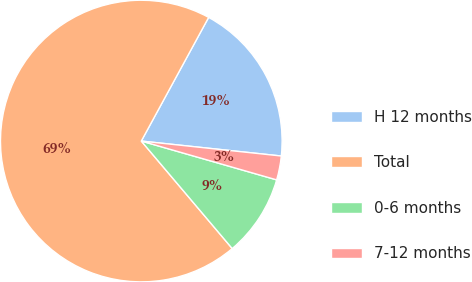Convert chart. <chart><loc_0><loc_0><loc_500><loc_500><pie_chart><fcel>H 12 months<fcel>Total<fcel>0-6 months<fcel>7-12 months<nl><fcel>18.76%<fcel>69.11%<fcel>9.38%<fcel>2.75%<nl></chart> 